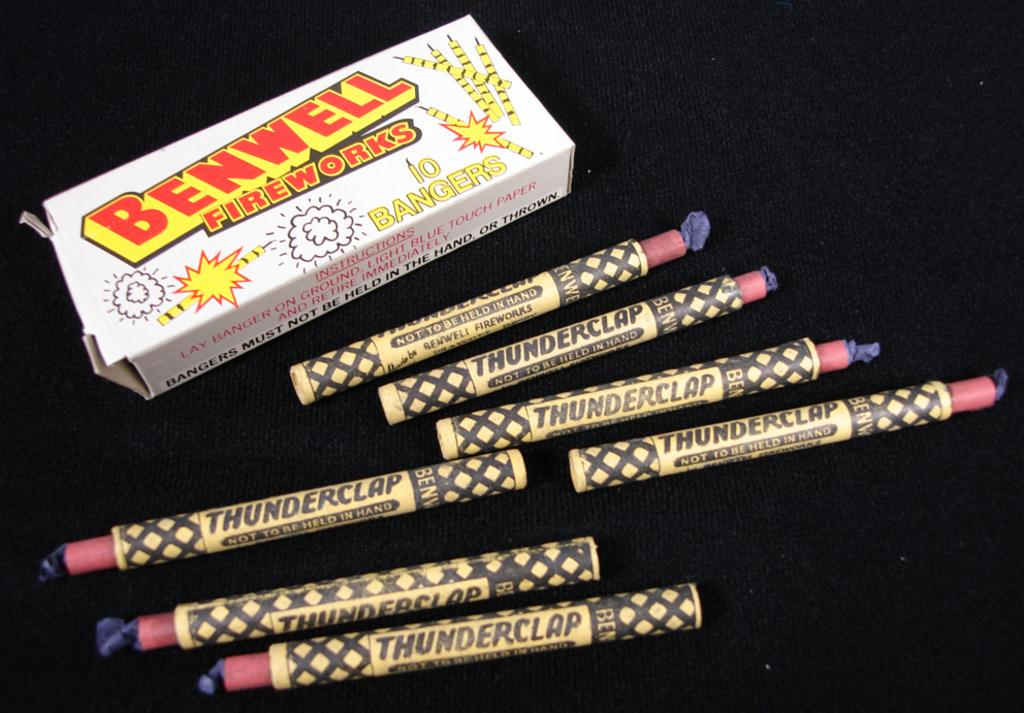Provide a one-sentence caption for the provided image. A pack of 7 Thunderclaps from Benwell Fireworks. 